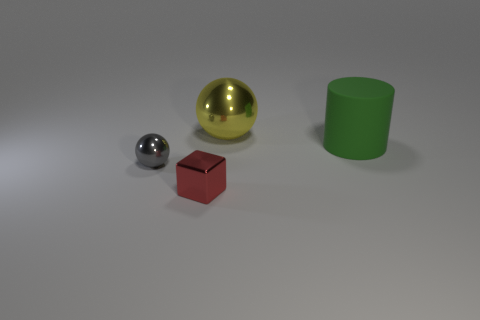Add 2 small green matte cylinders. How many objects exist? 6 Subtract all blocks. How many objects are left? 3 Add 4 small yellow blocks. How many small yellow blocks exist? 4 Subtract 0 yellow cylinders. How many objects are left? 4 Subtract all large brown matte blocks. Subtract all big rubber things. How many objects are left? 3 Add 3 yellow shiny things. How many yellow shiny things are left? 4 